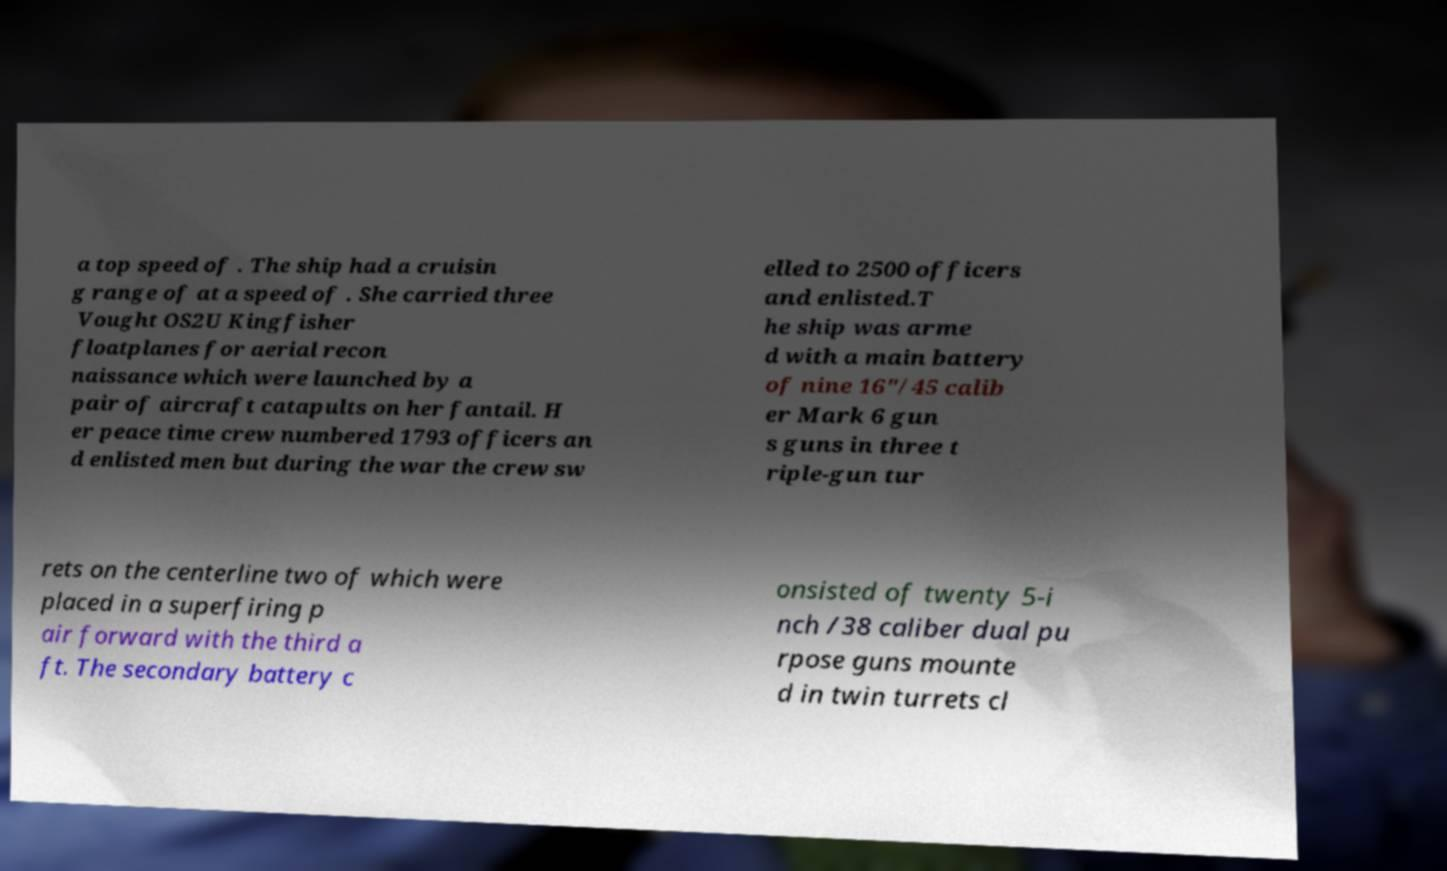I need the written content from this picture converted into text. Can you do that? a top speed of . The ship had a cruisin g range of at a speed of . She carried three Vought OS2U Kingfisher floatplanes for aerial recon naissance which were launched by a pair of aircraft catapults on her fantail. H er peace time crew numbered 1793 officers an d enlisted men but during the war the crew sw elled to 2500 officers and enlisted.T he ship was arme d with a main battery of nine 16"/45 calib er Mark 6 gun s guns in three t riple-gun tur rets on the centerline two of which were placed in a superfiring p air forward with the third a ft. The secondary battery c onsisted of twenty 5-i nch /38 caliber dual pu rpose guns mounte d in twin turrets cl 